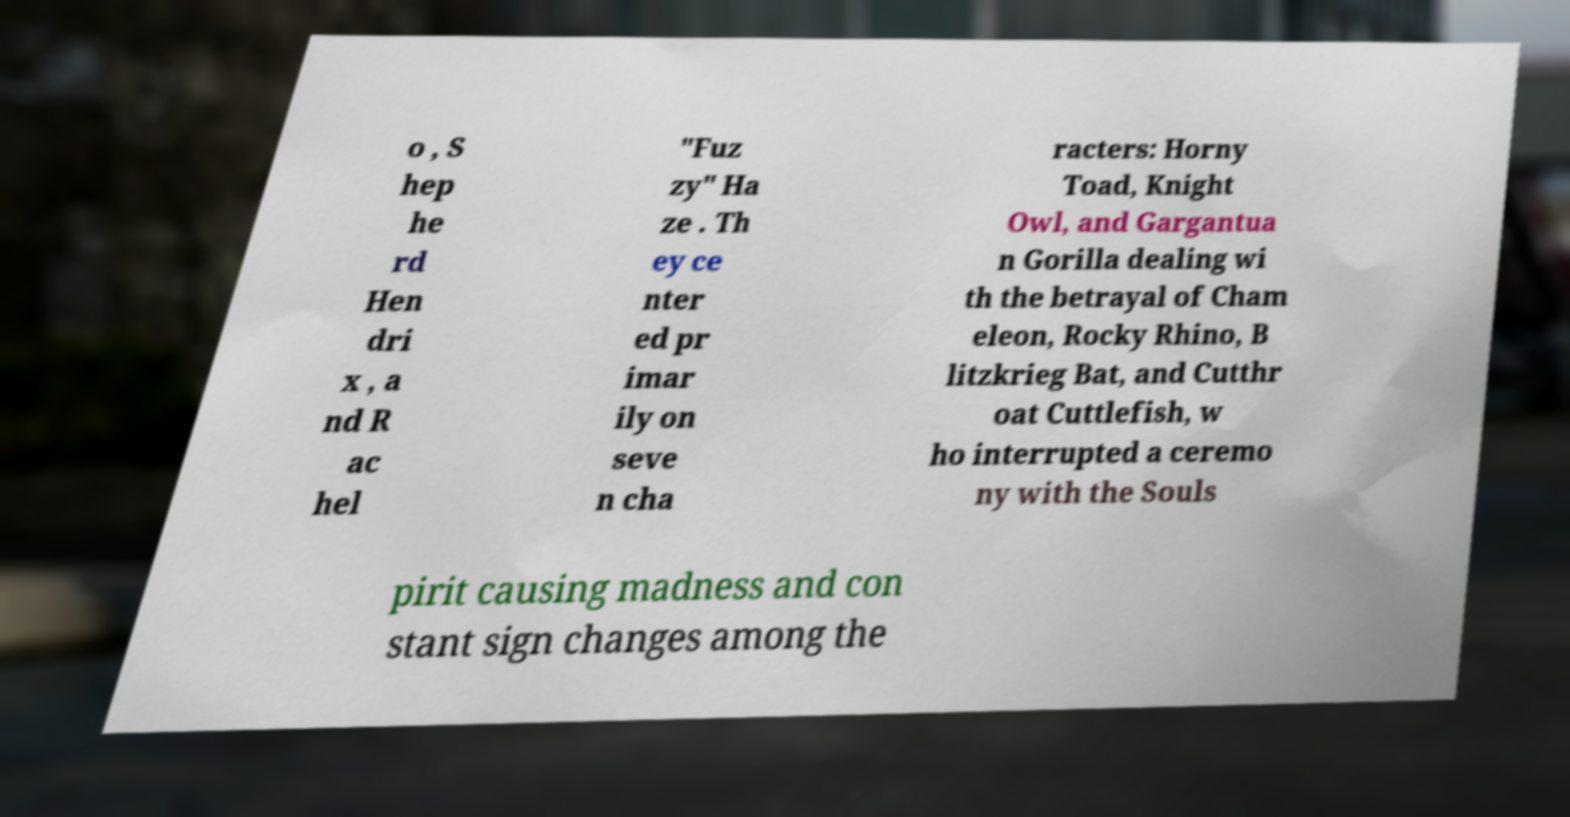Could you assist in decoding the text presented in this image and type it out clearly? o , S hep he rd Hen dri x , a nd R ac hel "Fuz zy" Ha ze . Th ey ce nter ed pr imar ily on seve n cha racters: Horny Toad, Knight Owl, and Gargantua n Gorilla dealing wi th the betrayal of Cham eleon, Rocky Rhino, B litzkrieg Bat, and Cutthr oat Cuttlefish, w ho interrupted a ceremo ny with the Souls pirit causing madness and con stant sign changes among the 